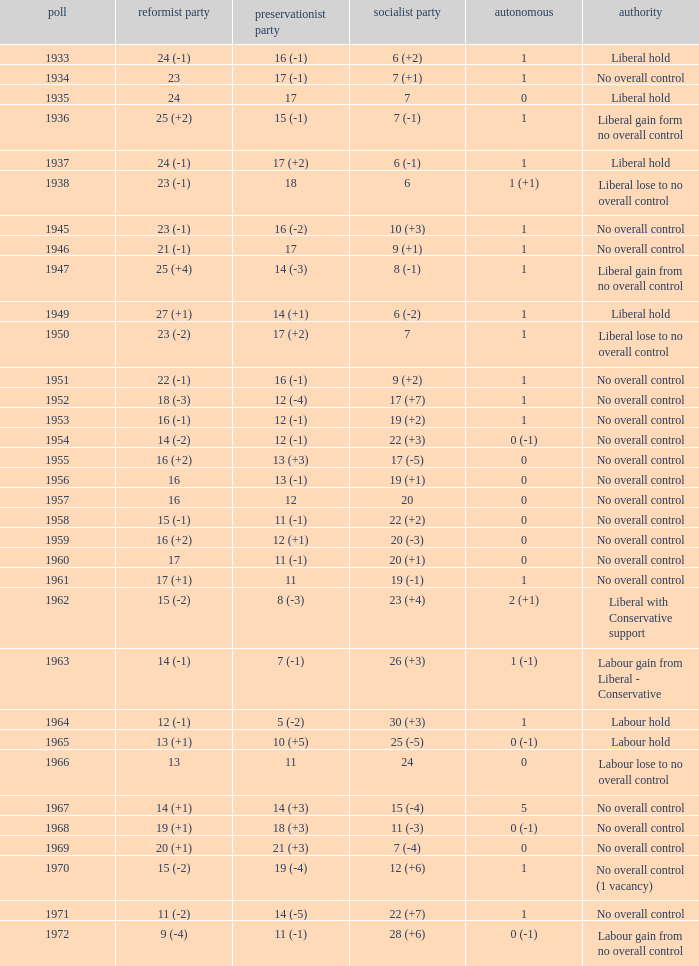What is the number of Independents elected in the year Labour won 26 (+3) seats? 1 (-1). 